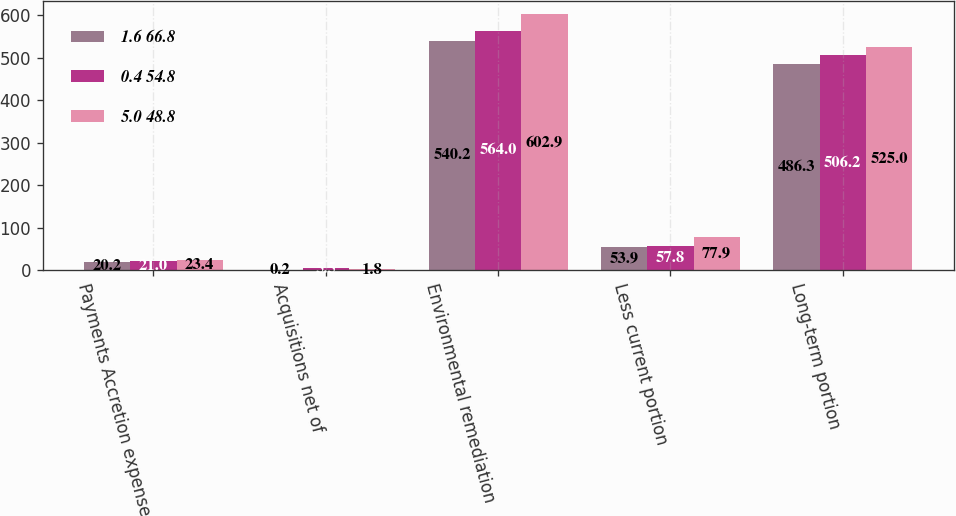Convert chart. <chart><loc_0><loc_0><loc_500><loc_500><stacked_bar_chart><ecel><fcel>Payments Accretion expense<fcel>Acquisitions net of<fcel>Environmental remediation<fcel>Less current portion<fcel>Long-term portion<nl><fcel>1.6 66.8<fcel>20.2<fcel>0.2<fcel>540.2<fcel>53.9<fcel>486.3<nl><fcel>0.4 54.8<fcel>21<fcel>5.5<fcel>564<fcel>57.8<fcel>506.2<nl><fcel>5.0 48.8<fcel>23.4<fcel>1.8<fcel>602.9<fcel>77.9<fcel>525<nl></chart> 